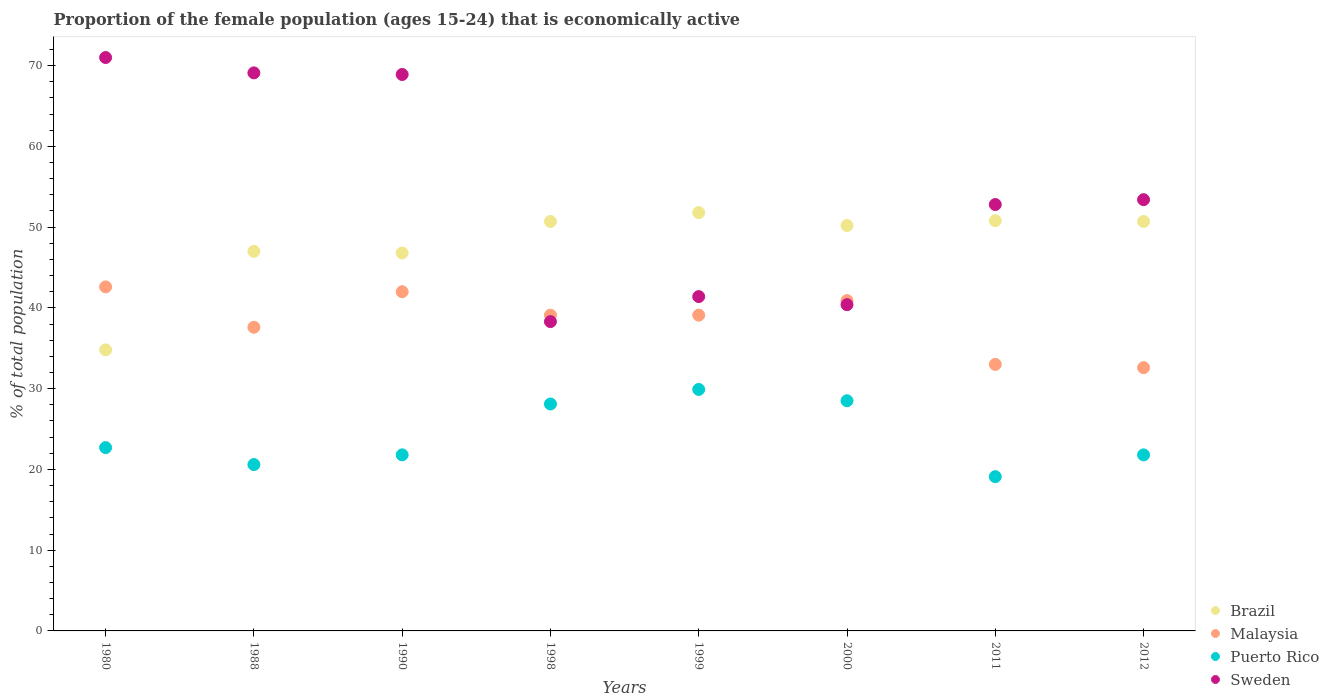Is the number of dotlines equal to the number of legend labels?
Your answer should be compact. Yes. What is the proportion of the female population that is economically active in Puerto Rico in 1998?
Your response must be concise. 28.1. Across all years, what is the maximum proportion of the female population that is economically active in Puerto Rico?
Offer a very short reply. 29.9. Across all years, what is the minimum proportion of the female population that is economically active in Brazil?
Make the answer very short. 34.8. In which year was the proportion of the female population that is economically active in Malaysia maximum?
Offer a very short reply. 1980. What is the total proportion of the female population that is economically active in Sweden in the graph?
Your answer should be very brief. 435.3. What is the difference between the proportion of the female population that is economically active in Malaysia in 1990 and that in 2000?
Provide a short and direct response. 1.1. What is the difference between the proportion of the female population that is economically active in Puerto Rico in 1988 and the proportion of the female population that is economically active in Malaysia in 1980?
Give a very brief answer. -22. What is the average proportion of the female population that is economically active in Puerto Rico per year?
Offer a terse response. 24.06. In the year 1999, what is the difference between the proportion of the female population that is economically active in Puerto Rico and proportion of the female population that is economically active in Malaysia?
Your answer should be very brief. -9.2. In how many years, is the proportion of the female population that is economically active in Brazil greater than 58 %?
Offer a very short reply. 0. What is the ratio of the proportion of the female population that is economically active in Sweden in 1999 to that in 2011?
Provide a short and direct response. 0.78. Is the difference between the proportion of the female population that is economically active in Puerto Rico in 1990 and 1999 greater than the difference between the proportion of the female population that is economically active in Malaysia in 1990 and 1999?
Ensure brevity in your answer.  No. What is the difference between the highest and the second highest proportion of the female population that is economically active in Puerto Rico?
Ensure brevity in your answer.  1.4. What is the difference between the highest and the lowest proportion of the female population that is economically active in Brazil?
Offer a terse response. 17. How many dotlines are there?
Your response must be concise. 4. How many years are there in the graph?
Give a very brief answer. 8. What is the difference between two consecutive major ticks on the Y-axis?
Give a very brief answer. 10. Are the values on the major ticks of Y-axis written in scientific E-notation?
Your answer should be compact. No. Does the graph contain grids?
Your answer should be very brief. No. How many legend labels are there?
Your response must be concise. 4. What is the title of the graph?
Keep it short and to the point. Proportion of the female population (ages 15-24) that is economically active. What is the label or title of the Y-axis?
Keep it short and to the point. % of total population. What is the % of total population in Brazil in 1980?
Give a very brief answer. 34.8. What is the % of total population of Malaysia in 1980?
Keep it short and to the point. 42.6. What is the % of total population of Puerto Rico in 1980?
Your answer should be very brief. 22.7. What is the % of total population in Brazil in 1988?
Give a very brief answer. 47. What is the % of total population in Malaysia in 1988?
Your response must be concise. 37.6. What is the % of total population in Puerto Rico in 1988?
Your answer should be very brief. 20.6. What is the % of total population of Sweden in 1988?
Offer a very short reply. 69.1. What is the % of total population of Brazil in 1990?
Give a very brief answer. 46.8. What is the % of total population in Malaysia in 1990?
Your answer should be compact. 42. What is the % of total population of Puerto Rico in 1990?
Your response must be concise. 21.8. What is the % of total population of Sweden in 1990?
Offer a terse response. 68.9. What is the % of total population in Brazil in 1998?
Provide a succinct answer. 50.7. What is the % of total population of Malaysia in 1998?
Offer a terse response. 39.1. What is the % of total population in Puerto Rico in 1998?
Your answer should be very brief. 28.1. What is the % of total population in Sweden in 1998?
Ensure brevity in your answer.  38.3. What is the % of total population of Brazil in 1999?
Your response must be concise. 51.8. What is the % of total population in Malaysia in 1999?
Your answer should be very brief. 39.1. What is the % of total population in Puerto Rico in 1999?
Keep it short and to the point. 29.9. What is the % of total population of Sweden in 1999?
Your answer should be very brief. 41.4. What is the % of total population of Brazil in 2000?
Make the answer very short. 50.2. What is the % of total population of Malaysia in 2000?
Keep it short and to the point. 40.9. What is the % of total population of Sweden in 2000?
Make the answer very short. 40.4. What is the % of total population of Brazil in 2011?
Your answer should be compact. 50.8. What is the % of total population of Puerto Rico in 2011?
Your answer should be very brief. 19.1. What is the % of total population of Sweden in 2011?
Offer a terse response. 52.8. What is the % of total population in Brazil in 2012?
Offer a terse response. 50.7. What is the % of total population in Malaysia in 2012?
Your response must be concise. 32.6. What is the % of total population of Puerto Rico in 2012?
Ensure brevity in your answer.  21.8. What is the % of total population in Sweden in 2012?
Your answer should be compact. 53.4. Across all years, what is the maximum % of total population of Brazil?
Offer a very short reply. 51.8. Across all years, what is the maximum % of total population of Malaysia?
Provide a succinct answer. 42.6. Across all years, what is the maximum % of total population of Puerto Rico?
Your response must be concise. 29.9. Across all years, what is the minimum % of total population of Brazil?
Offer a very short reply. 34.8. Across all years, what is the minimum % of total population in Malaysia?
Ensure brevity in your answer.  32.6. Across all years, what is the minimum % of total population of Puerto Rico?
Provide a succinct answer. 19.1. Across all years, what is the minimum % of total population in Sweden?
Provide a short and direct response. 38.3. What is the total % of total population in Brazil in the graph?
Your answer should be compact. 382.8. What is the total % of total population in Malaysia in the graph?
Give a very brief answer. 306.9. What is the total % of total population in Puerto Rico in the graph?
Your answer should be compact. 192.5. What is the total % of total population of Sweden in the graph?
Your answer should be compact. 435.3. What is the difference between the % of total population in Brazil in 1980 and that in 1988?
Make the answer very short. -12.2. What is the difference between the % of total population in Puerto Rico in 1980 and that in 1988?
Offer a terse response. 2.1. What is the difference between the % of total population of Brazil in 1980 and that in 1990?
Give a very brief answer. -12. What is the difference between the % of total population of Malaysia in 1980 and that in 1990?
Give a very brief answer. 0.6. What is the difference between the % of total population of Brazil in 1980 and that in 1998?
Your response must be concise. -15.9. What is the difference between the % of total population of Sweden in 1980 and that in 1998?
Provide a short and direct response. 32.7. What is the difference between the % of total population in Malaysia in 1980 and that in 1999?
Offer a terse response. 3.5. What is the difference between the % of total population in Puerto Rico in 1980 and that in 1999?
Your answer should be very brief. -7.2. What is the difference between the % of total population of Sweden in 1980 and that in 1999?
Your answer should be very brief. 29.6. What is the difference between the % of total population of Brazil in 1980 and that in 2000?
Give a very brief answer. -15.4. What is the difference between the % of total population in Malaysia in 1980 and that in 2000?
Keep it short and to the point. 1.7. What is the difference between the % of total population of Puerto Rico in 1980 and that in 2000?
Ensure brevity in your answer.  -5.8. What is the difference between the % of total population in Sweden in 1980 and that in 2000?
Provide a short and direct response. 30.6. What is the difference between the % of total population in Malaysia in 1980 and that in 2011?
Give a very brief answer. 9.6. What is the difference between the % of total population of Brazil in 1980 and that in 2012?
Make the answer very short. -15.9. What is the difference between the % of total population of Malaysia in 1980 and that in 2012?
Provide a short and direct response. 10. What is the difference between the % of total population in Malaysia in 1988 and that in 1990?
Provide a succinct answer. -4.4. What is the difference between the % of total population in Puerto Rico in 1988 and that in 1990?
Make the answer very short. -1.2. What is the difference between the % of total population in Puerto Rico in 1988 and that in 1998?
Ensure brevity in your answer.  -7.5. What is the difference between the % of total population of Sweden in 1988 and that in 1998?
Give a very brief answer. 30.8. What is the difference between the % of total population of Sweden in 1988 and that in 1999?
Make the answer very short. 27.7. What is the difference between the % of total population in Sweden in 1988 and that in 2000?
Offer a very short reply. 28.7. What is the difference between the % of total population of Brazil in 1988 and that in 2011?
Your answer should be very brief. -3.8. What is the difference between the % of total population in Malaysia in 1988 and that in 2011?
Give a very brief answer. 4.6. What is the difference between the % of total population in Sweden in 1988 and that in 2011?
Give a very brief answer. 16.3. What is the difference between the % of total population of Malaysia in 1988 and that in 2012?
Provide a short and direct response. 5. What is the difference between the % of total population in Puerto Rico in 1988 and that in 2012?
Provide a short and direct response. -1.2. What is the difference between the % of total population in Sweden in 1988 and that in 2012?
Offer a very short reply. 15.7. What is the difference between the % of total population in Brazil in 1990 and that in 1998?
Provide a succinct answer. -3.9. What is the difference between the % of total population in Sweden in 1990 and that in 1998?
Your answer should be compact. 30.6. What is the difference between the % of total population of Brazil in 1990 and that in 1999?
Your answer should be very brief. -5. What is the difference between the % of total population of Malaysia in 1990 and that in 2000?
Your answer should be very brief. 1.1. What is the difference between the % of total population in Puerto Rico in 1990 and that in 2000?
Your answer should be compact. -6.7. What is the difference between the % of total population in Sweden in 1990 and that in 2000?
Your response must be concise. 28.5. What is the difference between the % of total population of Brazil in 1990 and that in 2011?
Ensure brevity in your answer.  -4. What is the difference between the % of total population in Brazil in 1990 and that in 2012?
Give a very brief answer. -3.9. What is the difference between the % of total population in Puerto Rico in 1990 and that in 2012?
Provide a succinct answer. 0. What is the difference between the % of total population in Sweden in 1990 and that in 2012?
Ensure brevity in your answer.  15.5. What is the difference between the % of total population in Sweden in 1998 and that in 1999?
Give a very brief answer. -3.1. What is the difference between the % of total population in Brazil in 1998 and that in 2000?
Offer a very short reply. 0.5. What is the difference between the % of total population in Malaysia in 1998 and that in 2000?
Your answer should be very brief. -1.8. What is the difference between the % of total population in Puerto Rico in 1998 and that in 2000?
Give a very brief answer. -0.4. What is the difference between the % of total population of Malaysia in 1998 and that in 2011?
Provide a short and direct response. 6.1. What is the difference between the % of total population in Puerto Rico in 1998 and that in 2011?
Make the answer very short. 9. What is the difference between the % of total population in Sweden in 1998 and that in 2011?
Make the answer very short. -14.5. What is the difference between the % of total population in Malaysia in 1998 and that in 2012?
Give a very brief answer. 6.5. What is the difference between the % of total population in Puerto Rico in 1998 and that in 2012?
Offer a very short reply. 6.3. What is the difference between the % of total population of Sweden in 1998 and that in 2012?
Keep it short and to the point. -15.1. What is the difference between the % of total population in Malaysia in 1999 and that in 2000?
Ensure brevity in your answer.  -1.8. What is the difference between the % of total population in Puerto Rico in 1999 and that in 2000?
Offer a very short reply. 1.4. What is the difference between the % of total population of Brazil in 1999 and that in 2011?
Your response must be concise. 1. What is the difference between the % of total population in Malaysia in 1999 and that in 2011?
Provide a short and direct response. 6.1. What is the difference between the % of total population in Puerto Rico in 1999 and that in 2011?
Give a very brief answer. 10.8. What is the difference between the % of total population in Brazil in 1999 and that in 2012?
Your answer should be compact. 1.1. What is the difference between the % of total population of Puerto Rico in 1999 and that in 2012?
Your answer should be very brief. 8.1. What is the difference between the % of total population of Sweden in 2000 and that in 2011?
Your response must be concise. -12.4. What is the difference between the % of total population in Malaysia in 2000 and that in 2012?
Provide a short and direct response. 8.3. What is the difference between the % of total population in Puerto Rico in 2000 and that in 2012?
Your answer should be very brief. 6.7. What is the difference between the % of total population in Puerto Rico in 2011 and that in 2012?
Offer a very short reply. -2.7. What is the difference between the % of total population of Sweden in 2011 and that in 2012?
Your response must be concise. -0.6. What is the difference between the % of total population in Brazil in 1980 and the % of total population in Puerto Rico in 1988?
Make the answer very short. 14.2. What is the difference between the % of total population of Brazil in 1980 and the % of total population of Sweden in 1988?
Your response must be concise. -34.3. What is the difference between the % of total population in Malaysia in 1980 and the % of total population in Sweden in 1988?
Your answer should be very brief. -26.5. What is the difference between the % of total population of Puerto Rico in 1980 and the % of total population of Sweden in 1988?
Your answer should be compact. -46.4. What is the difference between the % of total population of Brazil in 1980 and the % of total population of Malaysia in 1990?
Your answer should be compact. -7.2. What is the difference between the % of total population of Brazil in 1980 and the % of total population of Sweden in 1990?
Give a very brief answer. -34.1. What is the difference between the % of total population in Malaysia in 1980 and the % of total population in Puerto Rico in 1990?
Provide a succinct answer. 20.8. What is the difference between the % of total population of Malaysia in 1980 and the % of total population of Sweden in 1990?
Your answer should be very brief. -26.3. What is the difference between the % of total population in Puerto Rico in 1980 and the % of total population in Sweden in 1990?
Make the answer very short. -46.2. What is the difference between the % of total population of Brazil in 1980 and the % of total population of Malaysia in 1998?
Offer a very short reply. -4.3. What is the difference between the % of total population of Puerto Rico in 1980 and the % of total population of Sweden in 1998?
Your answer should be very brief. -15.6. What is the difference between the % of total population of Brazil in 1980 and the % of total population of Sweden in 1999?
Offer a terse response. -6.6. What is the difference between the % of total population in Puerto Rico in 1980 and the % of total population in Sweden in 1999?
Your response must be concise. -18.7. What is the difference between the % of total population of Brazil in 1980 and the % of total population of Sweden in 2000?
Offer a very short reply. -5.6. What is the difference between the % of total population of Malaysia in 1980 and the % of total population of Sweden in 2000?
Offer a terse response. 2.2. What is the difference between the % of total population in Puerto Rico in 1980 and the % of total population in Sweden in 2000?
Keep it short and to the point. -17.7. What is the difference between the % of total population in Brazil in 1980 and the % of total population in Malaysia in 2011?
Your answer should be compact. 1.8. What is the difference between the % of total population of Malaysia in 1980 and the % of total population of Puerto Rico in 2011?
Your answer should be compact. 23.5. What is the difference between the % of total population in Malaysia in 1980 and the % of total population in Sweden in 2011?
Your response must be concise. -10.2. What is the difference between the % of total population in Puerto Rico in 1980 and the % of total population in Sweden in 2011?
Provide a short and direct response. -30.1. What is the difference between the % of total population of Brazil in 1980 and the % of total population of Puerto Rico in 2012?
Make the answer very short. 13. What is the difference between the % of total population in Brazil in 1980 and the % of total population in Sweden in 2012?
Your response must be concise. -18.6. What is the difference between the % of total population of Malaysia in 1980 and the % of total population of Puerto Rico in 2012?
Ensure brevity in your answer.  20.8. What is the difference between the % of total population of Malaysia in 1980 and the % of total population of Sweden in 2012?
Provide a short and direct response. -10.8. What is the difference between the % of total population of Puerto Rico in 1980 and the % of total population of Sweden in 2012?
Provide a succinct answer. -30.7. What is the difference between the % of total population of Brazil in 1988 and the % of total population of Puerto Rico in 1990?
Your answer should be compact. 25.2. What is the difference between the % of total population of Brazil in 1988 and the % of total population of Sweden in 1990?
Your answer should be very brief. -21.9. What is the difference between the % of total population in Malaysia in 1988 and the % of total population in Sweden in 1990?
Keep it short and to the point. -31.3. What is the difference between the % of total population in Puerto Rico in 1988 and the % of total population in Sweden in 1990?
Your answer should be very brief. -48.3. What is the difference between the % of total population in Brazil in 1988 and the % of total population in Puerto Rico in 1998?
Give a very brief answer. 18.9. What is the difference between the % of total population in Malaysia in 1988 and the % of total population in Puerto Rico in 1998?
Your answer should be compact. 9.5. What is the difference between the % of total population of Malaysia in 1988 and the % of total population of Sweden in 1998?
Offer a very short reply. -0.7. What is the difference between the % of total population in Puerto Rico in 1988 and the % of total population in Sweden in 1998?
Keep it short and to the point. -17.7. What is the difference between the % of total population in Malaysia in 1988 and the % of total population in Sweden in 1999?
Offer a very short reply. -3.8. What is the difference between the % of total population in Puerto Rico in 1988 and the % of total population in Sweden in 1999?
Your answer should be very brief. -20.8. What is the difference between the % of total population in Brazil in 1988 and the % of total population in Puerto Rico in 2000?
Make the answer very short. 18.5. What is the difference between the % of total population in Malaysia in 1988 and the % of total population in Sweden in 2000?
Make the answer very short. -2.8. What is the difference between the % of total population of Puerto Rico in 1988 and the % of total population of Sweden in 2000?
Ensure brevity in your answer.  -19.8. What is the difference between the % of total population of Brazil in 1988 and the % of total population of Malaysia in 2011?
Provide a short and direct response. 14. What is the difference between the % of total population in Brazil in 1988 and the % of total population in Puerto Rico in 2011?
Provide a short and direct response. 27.9. What is the difference between the % of total population in Malaysia in 1988 and the % of total population in Sweden in 2011?
Make the answer very short. -15.2. What is the difference between the % of total population in Puerto Rico in 1988 and the % of total population in Sweden in 2011?
Your answer should be compact. -32.2. What is the difference between the % of total population in Brazil in 1988 and the % of total population in Puerto Rico in 2012?
Provide a short and direct response. 25.2. What is the difference between the % of total population of Malaysia in 1988 and the % of total population of Puerto Rico in 2012?
Keep it short and to the point. 15.8. What is the difference between the % of total population of Malaysia in 1988 and the % of total population of Sweden in 2012?
Give a very brief answer. -15.8. What is the difference between the % of total population of Puerto Rico in 1988 and the % of total population of Sweden in 2012?
Offer a very short reply. -32.8. What is the difference between the % of total population in Malaysia in 1990 and the % of total population in Puerto Rico in 1998?
Offer a terse response. 13.9. What is the difference between the % of total population of Malaysia in 1990 and the % of total population of Sweden in 1998?
Give a very brief answer. 3.7. What is the difference between the % of total population of Puerto Rico in 1990 and the % of total population of Sweden in 1998?
Provide a succinct answer. -16.5. What is the difference between the % of total population of Brazil in 1990 and the % of total population of Puerto Rico in 1999?
Offer a terse response. 16.9. What is the difference between the % of total population in Malaysia in 1990 and the % of total population in Sweden in 1999?
Offer a very short reply. 0.6. What is the difference between the % of total population of Puerto Rico in 1990 and the % of total population of Sweden in 1999?
Your response must be concise. -19.6. What is the difference between the % of total population of Brazil in 1990 and the % of total population of Sweden in 2000?
Ensure brevity in your answer.  6.4. What is the difference between the % of total population in Puerto Rico in 1990 and the % of total population in Sweden in 2000?
Your response must be concise. -18.6. What is the difference between the % of total population of Brazil in 1990 and the % of total population of Puerto Rico in 2011?
Provide a short and direct response. 27.7. What is the difference between the % of total population in Brazil in 1990 and the % of total population in Sweden in 2011?
Make the answer very short. -6. What is the difference between the % of total population in Malaysia in 1990 and the % of total population in Puerto Rico in 2011?
Give a very brief answer. 22.9. What is the difference between the % of total population in Malaysia in 1990 and the % of total population in Sweden in 2011?
Your answer should be very brief. -10.8. What is the difference between the % of total population in Puerto Rico in 1990 and the % of total population in Sweden in 2011?
Offer a very short reply. -31. What is the difference between the % of total population in Brazil in 1990 and the % of total population in Malaysia in 2012?
Your answer should be compact. 14.2. What is the difference between the % of total population of Malaysia in 1990 and the % of total population of Puerto Rico in 2012?
Make the answer very short. 20.2. What is the difference between the % of total population of Puerto Rico in 1990 and the % of total population of Sweden in 2012?
Your answer should be compact. -31.6. What is the difference between the % of total population of Brazil in 1998 and the % of total population of Malaysia in 1999?
Your answer should be very brief. 11.6. What is the difference between the % of total population of Brazil in 1998 and the % of total population of Puerto Rico in 1999?
Offer a terse response. 20.8. What is the difference between the % of total population in Puerto Rico in 1998 and the % of total population in Sweden in 1999?
Ensure brevity in your answer.  -13.3. What is the difference between the % of total population of Brazil in 1998 and the % of total population of Malaysia in 2000?
Make the answer very short. 9.8. What is the difference between the % of total population of Brazil in 1998 and the % of total population of Puerto Rico in 2000?
Your answer should be very brief. 22.2. What is the difference between the % of total population in Malaysia in 1998 and the % of total population in Puerto Rico in 2000?
Your response must be concise. 10.6. What is the difference between the % of total population in Brazil in 1998 and the % of total population in Malaysia in 2011?
Provide a short and direct response. 17.7. What is the difference between the % of total population of Brazil in 1998 and the % of total population of Puerto Rico in 2011?
Keep it short and to the point. 31.6. What is the difference between the % of total population of Malaysia in 1998 and the % of total population of Puerto Rico in 2011?
Keep it short and to the point. 20. What is the difference between the % of total population of Malaysia in 1998 and the % of total population of Sweden in 2011?
Your response must be concise. -13.7. What is the difference between the % of total population in Puerto Rico in 1998 and the % of total population in Sweden in 2011?
Your answer should be compact. -24.7. What is the difference between the % of total population of Brazil in 1998 and the % of total population of Malaysia in 2012?
Offer a terse response. 18.1. What is the difference between the % of total population of Brazil in 1998 and the % of total population of Puerto Rico in 2012?
Your response must be concise. 28.9. What is the difference between the % of total population of Brazil in 1998 and the % of total population of Sweden in 2012?
Give a very brief answer. -2.7. What is the difference between the % of total population of Malaysia in 1998 and the % of total population of Puerto Rico in 2012?
Offer a very short reply. 17.3. What is the difference between the % of total population in Malaysia in 1998 and the % of total population in Sweden in 2012?
Make the answer very short. -14.3. What is the difference between the % of total population of Puerto Rico in 1998 and the % of total population of Sweden in 2012?
Offer a very short reply. -25.3. What is the difference between the % of total population of Brazil in 1999 and the % of total population of Puerto Rico in 2000?
Ensure brevity in your answer.  23.3. What is the difference between the % of total population in Malaysia in 1999 and the % of total population in Puerto Rico in 2000?
Your response must be concise. 10.6. What is the difference between the % of total population of Brazil in 1999 and the % of total population of Malaysia in 2011?
Offer a very short reply. 18.8. What is the difference between the % of total population in Brazil in 1999 and the % of total population in Puerto Rico in 2011?
Offer a very short reply. 32.7. What is the difference between the % of total population of Brazil in 1999 and the % of total population of Sweden in 2011?
Keep it short and to the point. -1. What is the difference between the % of total population of Malaysia in 1999 and the % of total population of Sweden in 2011?
Your answer should be very brief. -13.7. What is the difference between the % of total population of Puerto Rico in 1999 and the % of total population of Sweden in 2011?
Your response must be concise. -22.9. What is the difference between the % of total population of Brazil in 1999 and the % of total population of Sweden in 2012?
Provide a short and direct response. -1.6. What is the difference between the % of total population of Malaysia in 1999 and the % of total population of Puerto Rico in 2012?
Your answer should be very brief. 17.3. What is the difference between the % of total population in Malaysia in 1999 and the % of total population in Sweden in 2012?
Ensure brevity in your answer.  -14.3. What is the difference between the % of total population of Puerto Rico in 1999 and the % of total population of Sweden in 2012?
Your answer should be very brief. -23.5. What is the difference between the % of total population in Brazil in 2000 and the % of total population in Puerto Rico in 2011?
Give a very brief answer. 31.1. What is the difference between the % of total population of Malaysia in 2000 and the % of total population of Puerto Rico in 2011?
Keep it short and to the point. 21.8. What is the difference between the % of total population in Puerto Rico in 2000 and the % of total population in Sweden in 2011?
Provide a succinct answer. -24.3. What is the difference between the % of total population in Brazil in 2000 and the % of total population in Malaysia in 2012?
Your response must be concise. 17.6. What is the difference between the % of total population in Brazil in 2000 and the % of total population in Puerto Rico in 2012?
Make the answer very short. 28.4. What is the difference between the % of total population in Brazil in 2000 and the % of total population in Sweden in 2012?
Your response must be concise. -3.2. What is the difference between the % of total population of Malaysia in 2000 and the % of total population of Puerto Rico in 2012?
Your response must be concise. 19.1. What is the difference between the % of total population of Malaysia in 2000 and the % of total population of Sweden in 2012?
Offer a terse response. -12.5. What is the difference between the % of total population of Puerto Rico in 2000 and the % of total population of Sweden in 2012?
Keep it short and to the point. -24.9. What is the difference between the % of total population in Brazil in 2011 and the % of total population in Malaysia in 2012?
Your response must be concise. 18.2. What is the difference between the % of total population in Brazil in 2011 and the % of total population in Puerto Rico in 2012?
Keep it short and to the point. 29. What is the difference between the % of total population in Malaysia in 2011 and the % of total population in Puerto Rico in 2012?
Your answer should be very brief. 11.2. What is the difference between the % of total population of Malaysia in 2011 and the % of total population of Sweden in 2012?
Make the answer very short. -20.4. What is the difference between the % of total population of Puerto Rico in 2011 and the % of total population of Sweden in 2012?
Offer a very short reply. -34.3. What is the average % of total population in Brazil per year?
Provide a succinct answer. 47.85. What is the average % of total population in Malaysia per year?
Offer a very short reply. 38.36. What is the average % of total population in Puerto Rico per year?
Your answer should be compact. 24.06. What is the average % of total population in Sweden per year?
Ensure brevity in your answer.  54.41. In the year 1980, what is the difference between the % of total population of Brazil and % of total population of Sweden?
Offer a very short reply. -36.2. In the year 1980, what is the difference between the % of total population in Malaysia and % of total population in Sweden?
Ensure brevity in your answer.  -28.4. In the year 1980, what is the difference between the % of total population of Puerto Rico and % of total population of Sweden?
Provide a short and direct response. -48.3. In the year 1988, what is the difference between the % of total population in Brazil and % of total population in Puerto Rico?
Make the answer very short. 26.4. In the year 1988, what is the difference between the % of total population of Brazil and % of total population of Sweden?
Offer a terse response. -22.1. In the year 1988, what is the difference between the % of total population of Malaysia and % of total population of Sweden?
Offer a terse response. -31.5. In the year 1988, what is the difference between the % of total population in Puerto Rico and % of total population in Sweden?
Make the answer very short. -48.5. In the year 1990, what is the difference between the % of total population of Brazil and % of total population of Puerto Rico?
Keep it short and to the point. 25. In the year 1990, what is the difference between the % of total population in Brazil and % of total population in Sweden?
Your response must be concise. -22.1. In the year 1990, what is the difference between the % of total population in Malaysia and % of total population in Puerto Rico?
Keep it short and to the point. 20.2. In the year 1990, what is the difference between the % of total population in Malaysia and % of total population in Sweden?
Keep it short and to the point. -26.9. In the year 1990, what is the difference between the % of total population in Puerto Rico and % of total population in Sweden?
Provide a short and direct response. -47.1. In the year 1998, what is the difference between the % of total population of Brazil and % of total population of Puerto Rico?
Offer a terse response. 22.6. In the year 1998, what is the difference between the % of total population of Brazil and % of total population of Sweden?
Give a very brief answer. 12.4. In the year 1998, what is the difference between the % of total population of Malaysia and % of total population of Puerto Rico?
Keep it short and to the point. 11. In the year 1998, what is the difference between the % of total population of Malaysia and % of total population of Sweden?
Your answer should be compact. 0.8. In the year 1999, what is the difference between the % of total population of Brazil and % of total population of Malaysia?
Make the answer very short. 12.7. In the year 1999, what is the difference between the % of total population of Brazil and % of total population of Puerto Rico?
Ensure brevity in your answer.  21.9. In the year 1999, what is the difference between the % of total population in Puerto Rico and % of total population in Sweden?
Provide a short and direct response. -11.5. In the year 2000, what is the difference between the % of total population of Brazil and % of total population of Malaysia?
Keep it short and to the point. 9.3. In the year 2000, what is the difference between the % of total population in Brazil and % of total population in Puerto Rico?
Make the answer very short. 21.7. In the year 2000, what is the difference between the % of total population of Puerto Rico and % of total population of Sweden?
Keep it short and to the point. -11.9. In the year 2011, what is the difference between the % of total population in Brazil and % of total population in Malaysia?
Your answer should be very brief. 17.8. In the year 2011, what is the difference between the % of total population of Brazil and % of total population of Puerto Rico?
Offer a terse response. 31.7. In the year 2011, what is the difference between the % of total population in Brazil and % of total population in Sweden?
Offer a terse response. -2. In the year 2011, what is the difference between the % of total population in Malaysia and % of total population in Puerto Rico?
Make the answer very short. 13.9. In the year 2011, what is the difference between the % of total population in Malaysia and % of total population in Sweden?
Offer a very short reply. -19.8. In the year 2011, what is the difference between the % of total population in Puerto Rico and % of total population in Sweden?
Provide a short and direct response. -33.7. In the year 2012, what is the difference between the % of total population of Brazil and % of total population of Puerto Rico?
Offer a very short reply. 28.9. In the year 2012, what is the difference between the % of total population in Malaysia and % of total population in Sweden?
Offer a very short reply. -20.8. In the year 2012, what is the difference between the % of total population in Puerto Rico and % of total population in Sweden?
Your response must be concise. -31.6. What is the ratio of the % of total population of Brazil in 1980 to that in 1988?
Keep it short and to the point. 0.74. What is the ratio of the % of total population of Malaysia in 1980 to that in 1988?
Offer a very short reply. 1.13. What is the ratio of the % of total population of Puerto Rico in 1980 to that in 1988?
Provide a short and direct response. 1.1. What is the ratio of the % of total population of Sweden in 1980 to that in 1988?
Provide a short and direct response. 1.03. What is the ratio of the % of total population in Brazil in 1980 to that in 1990?
Your answer should be very brief. 0.74. What is the ratio of the % of total population in Malaysia in 1980 to that in 1990?
Ensure brevity in your answer.  1.01. What is the ratio of the % of total population of Puerto Rico in 1980 to that in 1990?
Provide a short and direct response. 1.04. What is the ratio of the % of total population in Sweden in 1980 to that in 1990?
Keep it short and to the point. 1.03. What is the ratio of the % of total population of Brazil in 1980 to that in 1998?
Your response must be concise. 0.69. What is the ratio of the % of total population in Malaysia in 1980 to that in 1998?
Provide a short and direct response. 1.09. What is the ratio of the % of total population in Puerto Rico in 1980 to that in 1998?
Ensure brevity in your answer.  0.81. What is the ratio of the % of total population of Sweden in 1980 to that in 1998?
Offer a terse response. 1.85. What is the ratio of the % of total population of Brazil in 1980 to that in 1999?
Provide a short and direct response. 0.67. What is the ratio of the % of total population in Malaysia in 1980 to that in 1999?
Your answer should be compact. 1.09. What is the ratio of the % of total population of Puerto Rico in 1980 to that in 1999?
Make the answer very short. 0.76. What is the ratio of the % of total population of Sweden in 1980 to that in 1999?
Give a very brief answer. 1.72. What is the ratio of the % of total population of Brazil in 1980 to that in 2000?
Ensure brevity in your answer.  0.69. What is the ratio of the % of total population of Malaysia in 1980 to that in 2000?
Give a very brief answer. 1.04. What is the ratio of the % of total population in Puerto Rico in 1980 to that in 2000?
Offer a terse response. 0.8. What is the ratio of the % of total population of Sweden in 1980 to that in 2000?
Offer a terse response. 1.76. What is the ratio of the % of total population in Brazil in 1980 to that in 2011?
Ensure brevity in your answer.  0.69. What is the ratio of the % of total population in Malaysia in 1980 to that in 2011?
Your answer should be very brief. 1.29. What is the ratio of the % of total population in Puerto Rico in 1980 to that in 2011?
Give a very brief answer. 1.19. What is the ratio of the % of total population of Sweden in 1980 to that in 2011?
Offer a terse response. 1.34. What is the ratio of the % of total population of Brazil in 1980 to that in 2012?
Ensure brevity in your answer.  0.69. What is the ratio of the % of total population of Malaysia in 1980 to that in 2012?
Offer a terse response. 1.31. What is the ratio of the % of total population in Puerto Rico in 1980 to that in 2012?
Your answer should be compact. 1.04. What is the ratio of the % of total population of Sweden in 1980 to that in 2012?
Offer a very short reply. 1.33. What is the ratio of the % of total population of Brazil in 1988 to that in 1990?
Your answer should be very brief. 1. What is the ratio of the % of total population in Malaysia in 1988 to that in 1990?
Keep it short and to the point. 0.9. What is the ratio of the % of total population of Puerto Rico in 1988 to that in 1990?
Offer a very short reply. 0.94. What is the ratio of the % of total population of Brazil in 1988 to that in 1998?
Offer a terse response. 0.93. What is the ratio of the % of total population of Malaysia in 1988 to that in 1998?
Keep it short and to the point. 0.96. What is the ratio of the % of total population of Puerto Rico in 1988 to that in 1998?
Your answer should be very brief. 0.73. What is the ratio of the % of total population in Sweden in 1988 to that in 1998?
Give a very brief answer. 1.8. What is the ratio of the % of total population in Brazil in 1988 to that in 1999?
Keep it short and to the point. 0.91. What is the ratio of the % of total population of Malaysia in 1988 to that in 1999?
Your response must be concise. 0.96. What is the ratio of the % of total population of Puerto Rico in 1988 to that in 1999?
Give a very brief answer. 0.69. What is the ratio of the % of total population in Sweden in 1988 to that in 1999?
Offer a terse response. 1.67. What is the ratio of the % of total population of Brazil in 1988 to that in 2000?
Provide a short and direct response. 0.94. What is the ratio of the % of total population of Malaysia in 1988 to that in 2000?
Give a very brief answer. 0.92. What is the ratio of the % of total population in Puerto Rico in 1988 to that in 2000?
Offer a very short reply. 0.72. What is the ratio of the % of total population of Sweden in 1988 to that in 2000?
Ensure brevity in your answer.  1.71. What is the ratio of the % of total population of Brazil in 1988 to that in 2011?
Keep it short and to the point. 0.93. What is the ratio of the % of total population in Malaysia in 1988 to that in 2011?
Your answer should be compact. 1.14. What is the ratio of the % of total population of Puerto Rico in 1988 to that in 2011?
Offer a terse response. 1.08. What is the ratio of the % of total population in Sweden in 1988 to that in 2011?
Offer a terse response. 1.31. What is the ratio of the % of total population of Brazil in 1988 to that in 2012?
Provide a short and direct response. 0.93. What is the ratio of the % of total population of Malaysia in 1988 to that in 2012?
Ensure brevity in your answer.  1.15. What is the ratio of the % of total population of Puerto Rico in 1988 to that in 2012?
Offer a very short reply. 0.94. What is the ratio of the % of total population in Sweden in 1988 to that in 2012?
Give a very brief answer. 1.29. What is the ratio of the % of total population in Malaysia in 1990 to that in 1998?
Ensure brevity in your answer.  1.07. What is the ratio of the % of total population in Puerto Rico in 1990 to that in 1998?
Give a very brief answer. 0.78. What is the ratio of the % of total population of Sweden in 1990 to that in 1998?
Offer a terse response. 1.8. What is the ratio of the % of total population of Brazil in 1990 to that in 1999?
Your answer should be compact. 0.9. What is the ratio of the % of total population in Malaysia in 1990 to that in 1999?
Offer a terse response. 1.07. What is the ratio of the % of total population in Puerto Rico in 1990 to that in 1999?
Make the answer very short. 0.73. What is the ratio of the % of total population in Sweden in 1990 to that in 1999?
Your answer should be compact. 1.66. What is the ratio of the % of total population in Brazil in 1990 to that in 2000?
Keep it short and to the point. 0.93. What is the ratio of the % of total population of Malaysia in 1990 to that in 2000?
Provide a succinct answer. 1.03. What is the ratio of the % of total population in Puerto Rico in 1990 to that in 2000?
Your answer should be compact. 0.76. What is the ratio of the % of total population in Sweden in 1990 to that in 2000?
Your answer should be compact. 1.71. What is the ratio of the % of total population of Brazil in 1990 to that in 2011?
Ensure brevity in your answer.  0.92. What is the ratio of the % of total population in Malaysia in 1990 to that in 2011?
Keep it short and to the point. 1.27. What is the ratio of the % of total population of Puerto Rico in 1990 to that in 2011?
Keep it short and to the point. 1.14. What is the ratio of the % of total population in Sweden in 1990 to that in 2011?
Make the answer very short. 1.3. What is the ratio of the % of total population of Brazil in 1990 to that in 2012?
Your response must be concise. 0.92. What is the ratio of the % of total population in Malaysia in 1990 to that in 2012?
Your answer should be compact. 1.29. What is the ratio of the % of total population of Sweden in 1990 to that in 2012?
Ensure brevity in your answer.  1.29. What is the ratio of the % of total population in Brazil in 1998 to that in 1999?
Your response must be concise. 0.98. What is the ratio of the % of total population in Malaysia in 1998 to that in 1999?
Your answer should be very brief. 1. What is the ratio of the % of total population of Puerto Rico in 1998 to that in 1999?
Offer a very short reply. 0.94. What is the ratio of the % of total population in Sweden in 1998 to that in 1999?
Provide a short and direct response. 0.93. What is the ratio of the % of total population in Malaysia in 1998 to that in 2000?
Provide a succinct answer. 0.96. What is the ratio of the % of total population in Puerto Rico in 1998 to that in 2000?
Provide a short and direct response. 0.99. What is the ratio of the % of total population of Sweden in 1998 to that in 2000?
Ensure brevity in your answer.  0.95. What is the ratio of the % of total population of Brazil in 1998 to that in 2011?
Ensure brevity in your answer.  1. What is the ratio of the % of total population in Malaysia in 1998 to that in 2011?
Provide a succinct answer. 1.18. What is the ratio of the % of total population in Puerto Rico in 1998 to that in 2011?
Provide a short and direct response. 1.47. What is the ratio of the % of total population in Sweden in 1998 to that in 2011?
Your answer should be compact. 0.73. What is the ratio of the % of total population in Brazil in 1998 to that in 2012?
Keep it short and to the point. 1. What is the ratio of the % of total population of Malaysia in 1998 to that in 2012?
Offer a very short reply. 1.2. What is the ratio of the % of total population of Puerto Rico in 1998 to that in 2012?
Your answer should be very brief. 1.29. What is the ratio of the % of total population in Sweden in 1998 to that in 2012?
Give a very brief answer. 0.72. What is the ratio of the % of total population of Brazil in 1999 to that in 2000?
Give a very brief answer. 1.03. What is the ratio of the % of total population of Malaysia in 1999 to that in 2000?
Your answer should be very brief. 0.96. What is the ratio of the % of total population of Puerto Rico in 1999 to that in 2000?
Ensure brevity in your answer.  1.05. What is the ratio of the % of total population in Sweden in 1999 to that in 2000?
Provide a short and direct response. 1.02. What is the ratio of the % of total population in Brazil in 1999 to that in 2011?
Your response must be concise. 1.02. What is the ratio of the % of total population in Malaysia in 1999 to that in 2011?
Make the answer very short. 1.18. What is the ratio of the % of total population in Puerto Rico in 1999 to that in 2011?
Give a very brief answer. 1.57. What is the ratio of the % of total population in Sweden in 1999 to that in 2011?
Give a very brief answer. 0.78. What is the ratio of the % of total population in Brazil in 1999 to that in 2012?
Ensure brevity in your answer.  1.02. What is the ratio of the % of total population in Malaysia in 1999 to that in 2012?
Ensure brevity in your answer.  1.2. What is the ratio of the % of total population in Puerto Rico in 1999 to that in 2012?
Your response must be concise. 1.37. What is the ratio of the % of total population in Sweden in 1999 to that in 2012?
Provide a short and direct response. 0.78. What is the ratio of the % of total population in Malaysia in 2000 to that in 2011?
Provide a short and direct response. 1.24. What is the ratio of the % of total population in Puerto Rico in 2000 to that in 2011?
Give a very brief answer. 1.49. What is the ratio of the % of total population of Sweden in 2000 to that in 2011?
Your answer should be compact. 0.77. What is the ratio of the % of total population of Malaysia in 2000 to that in 2012?
Your answer should be very brief. 1.25. What is the ratio of the % of total population of Puerto Rico in 2000 to that in 2012?
Provide a succinct answer. 1.31. What is the ratio of the % of total population in Sweden in 2000 to that in 2012?
Provide a succinct answer. 0.76. What is the ratio of the % of total population in Brazil in 2011 to that in 2012?
Give a very brief answer. 1. What is the ratio of the % of total population in Malaysia in 2011 to that in 2012?
Offer a very short reply. 1.01. What is the ratio of the % of total population of Puerto Rico in 2011 to that in 2012?
Provide a short and direct response. 0.88. What is the difference between the highest and the second highest % of total population of Puerto Rico?
Offer a terse response. 1.4. What is the difference between the highest and the second highest % of total population in Sweden?
Provide a succinct answer. 1.9. What is the difference between the highest and the lowest % of total population in Brazil?
Provide a short and direct response. 17. What is the difference between the highest and the lowest % of total population of Malaysia?
Provide a succinct answer. 10. What is the difference between the highest and the lowest % of total population in Puerto Rico?
Provide a succinct answer. 10.8. What is the difference between the highest and the lowest % of total population in Sweden?
Offer a terse response. 32.7. 